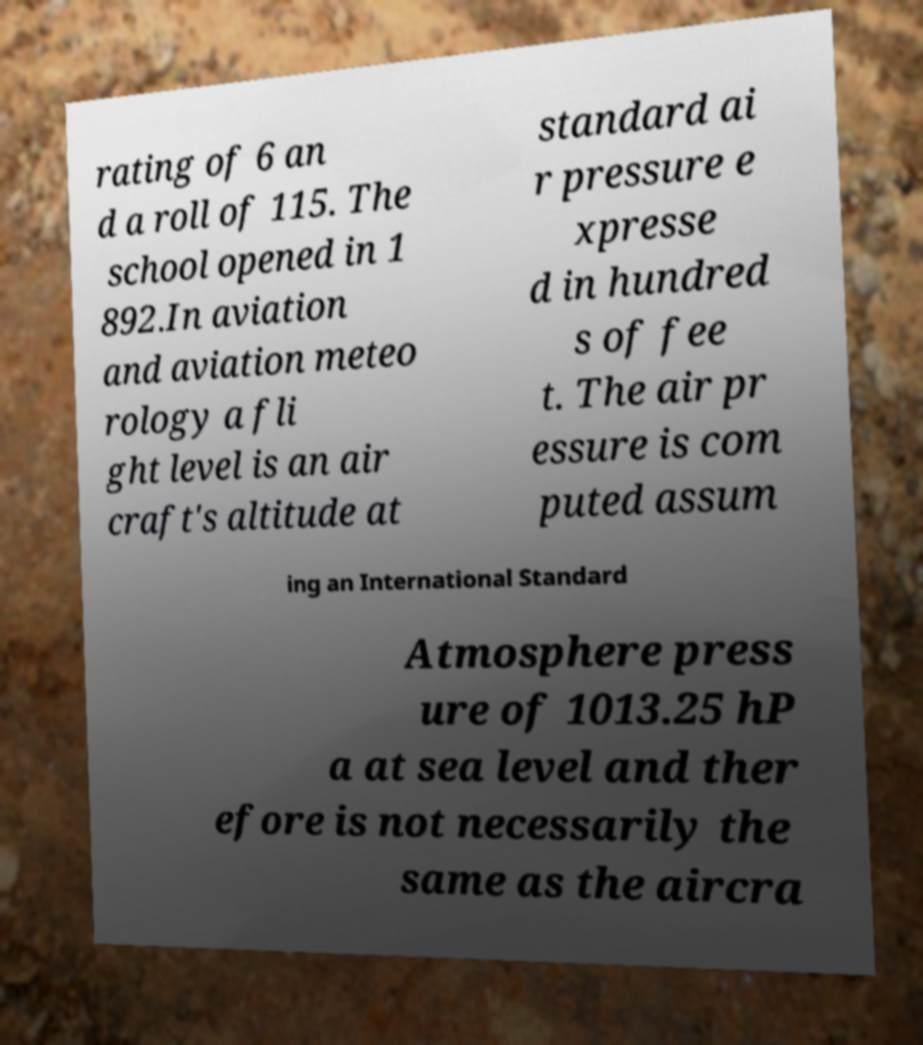What messages or text are displayed in this image? I need them in a readable, typed format. rating of 6 an d a roll of 115. The school opened in 1 892.In aviation and aviation meteo rology a fli ght level is an air craft's altitude at standard ai r pressure e xpresse d in hundred s of fee t. The air pr essure is com puted assum ing an International Standard Atmosphere press ure of 1013.25 hP a at sea level and ther efore is not necessarily the same as the aircra 